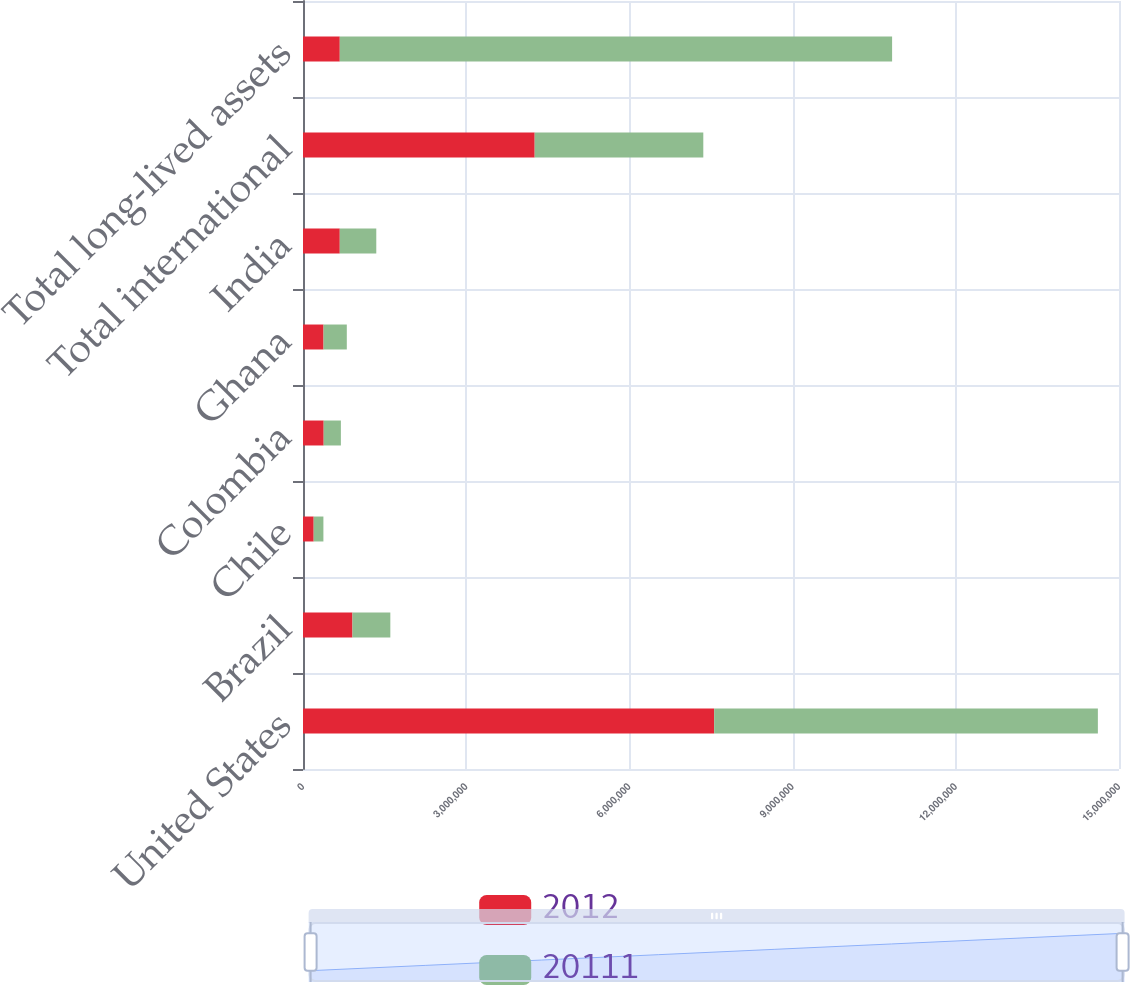Convert chart to OTSL. <chart><loc_0><loc_0><loc_500><loc_500><stacked_bar_chart><ecel><fcel>United States<fcel>Brazil<fcel>Chile<fcel>Colombia<fcel>Ghana<fcel>India<fcel>Total international<fcel>Total long-lived assets<nl><fcel>2012<fcel>7.55808e+06<fcel>909330<fcel>196387<fcel>380326<fcel>377553<fcel>676049<fcel>4.25902e+06<fcel>676049<nl><fcel>20111<fcel>7.0536e+06<fcel>695923<fcel>178670<fcel>316096<fcel>427759<fcel>671091<fcel>3.09947e+06<fcel>1.01531e+07<nl></chart> 